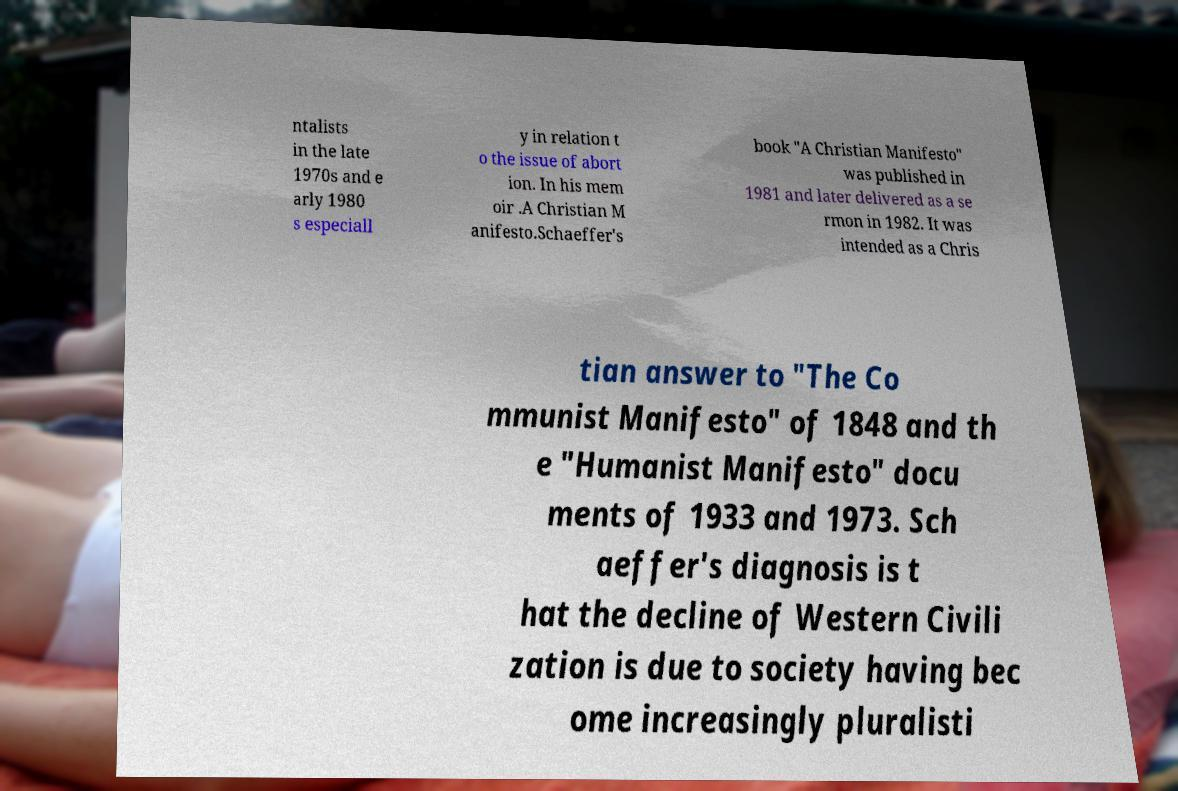I need the written content from this picture converted into text. Can you do that? ntalists in the late 1970s and e arly 1980 s especiall y in relation t o the issue of abort ion. In his mem oir .A Christian M anifesto.Schaeffer's book "A Christian Manifesto" was published in 1981 and later delivered as a se rmon in 1982. It was intended as a Chris tian answer to "The Co mmunist Manifesto" of 1848 and th e "Humanist Manifesto" docu ments of 1933 and 1973. Sch aeffer's diagnosis is t hat the decline of Western Civili zation is due to society having bec ome increasingly pluralisti 